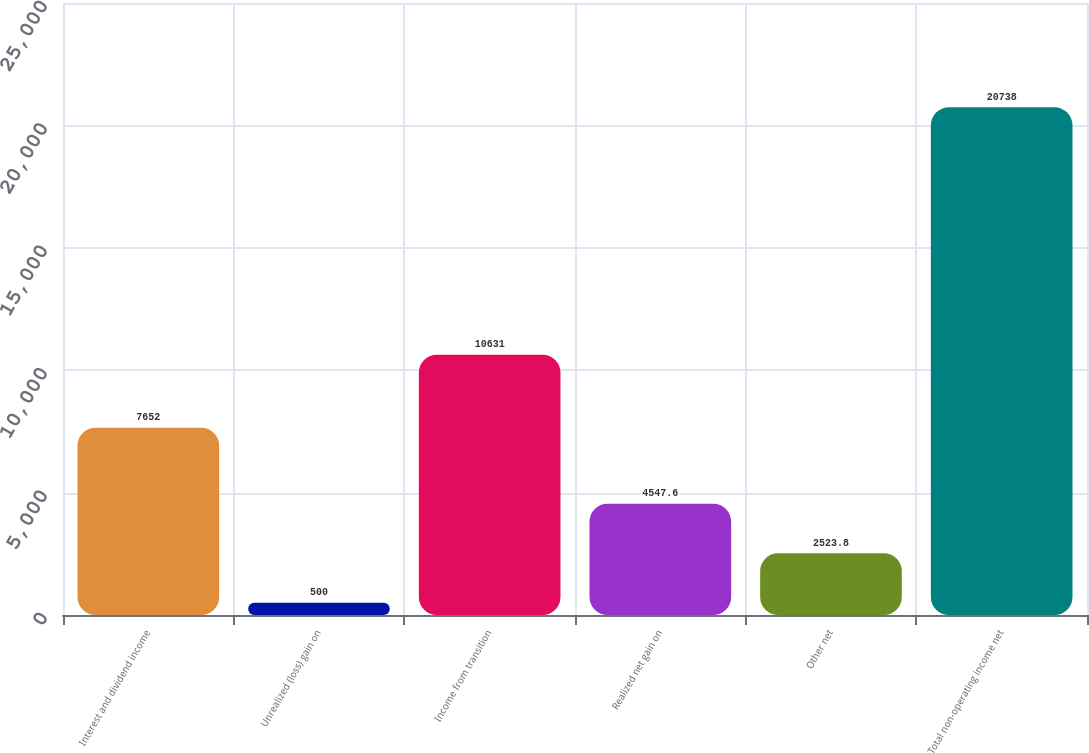Convert chart. <chart><loc_0><loc_0><loc_500><loc_500><bar_chart><fcel>Interest and dividend income<fcel>Unrealized (loss) gain on<fcel>Income from transition<fcel>Realized net gain on<fcel>Other net<fcel>Total non-operating income net<nl><fcel>7652<fcel>500<fcel>10631<fcel>4547.6<fcel>2523.8<fcel>20738<nl></chart> 